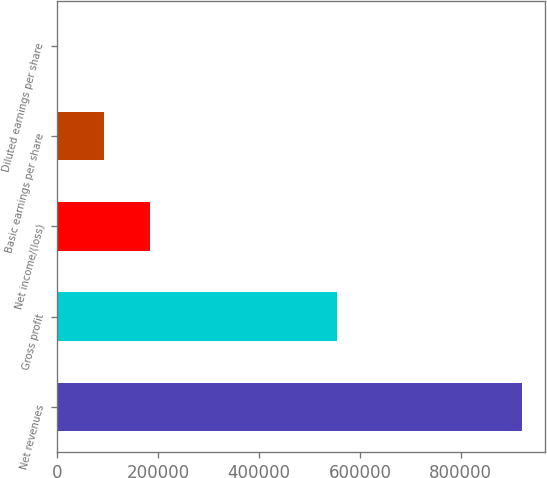<chart> <loc_0><loc_0><loc_500><loc_500><bar_chart><fcel>Net revenues<fcel>Gross profit<fcel>Net income/(loss)<fcel>Basic earnings per share<fcel>Diluted earnings per share<nl><fcel>920735<fcel>553802<fcel>184149<fcel>92075.2<fcel>1.9<nl></chart> 